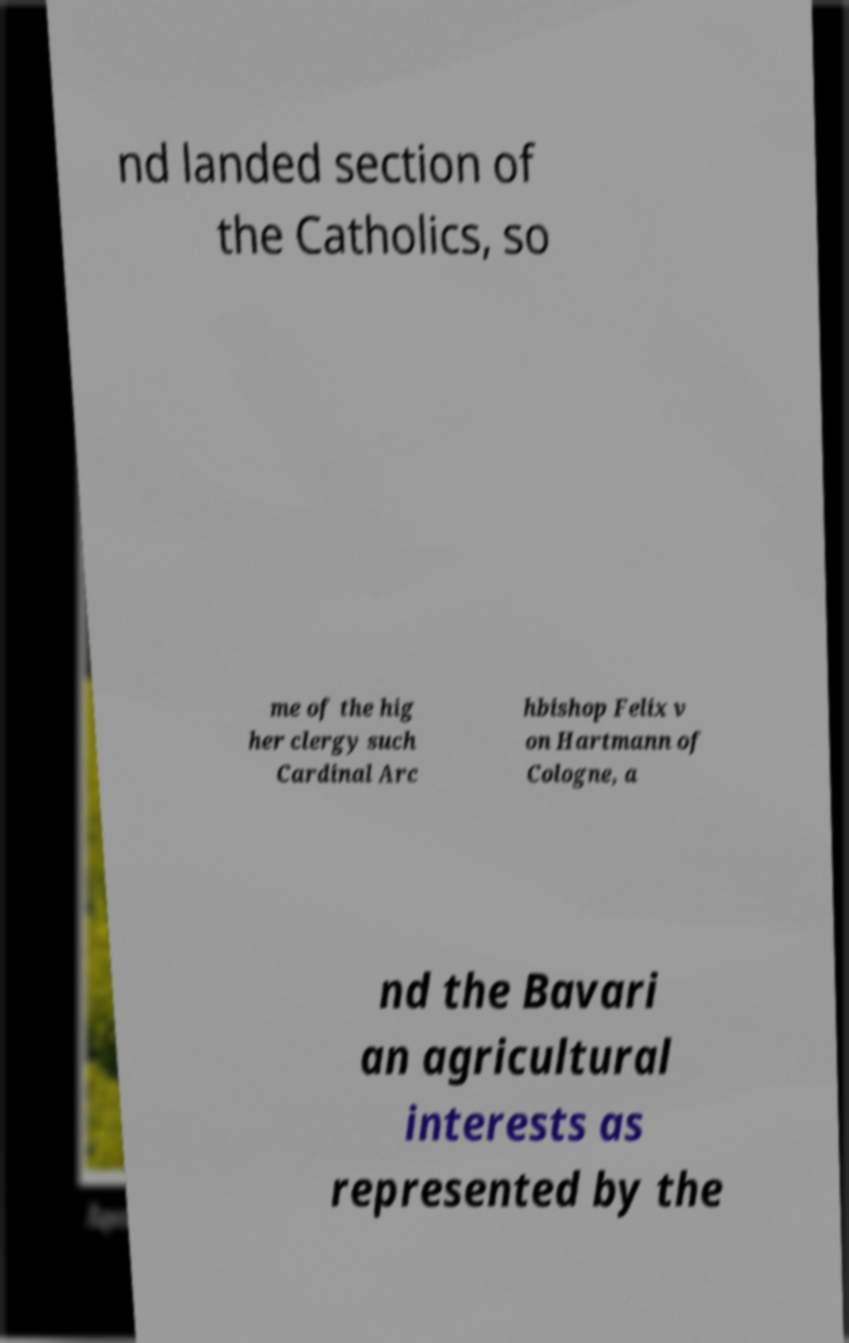Can you read and provide the text displayed in the image?This photo seems to have some interesting text. Can you extract and type it out for me? nd landed section of the Catholics, so me of the hig her clergy such Cardinal Arc hbishop Felix v on Hartmann of Cologne, a nd the Bavari an agricultural interests as represented by the 